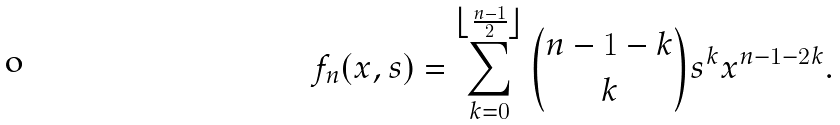<formula> <loc_0><loc_0><loc_500><loc_500>f _ { n } ( x , s ) = \sum _ { k = 0 } ^ { \left \lfloor \frac { n - 1 } { 2 } \right \rfloor } { n - 1 - k \choose k } s ^ { k } x ^ { n - 1 - 2 k } .</formula> 